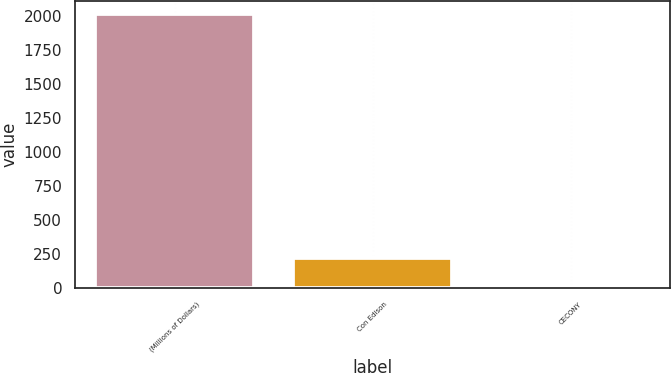Convert chart. <chart><loc_0><loc_0><loc_500><loc_500><bar_chart><fcel>(Millions of Dollars)<fcel>Con Edison<fcel>CECONY<nl><fcel>2013<fcel>215.7<fcel>16<nl></chart> 